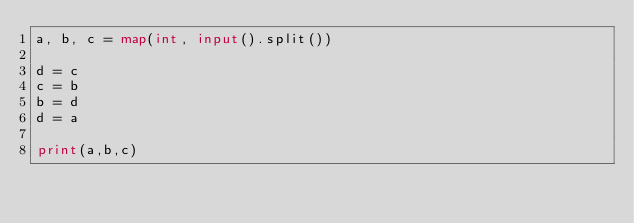Convert code to text. <code><loc_0><loc_0><loc_500><loc_500><_Python_>a, b, c = map(int, input().split())

d = c
c = b 
b = d
d = a
 
print(a,b,c)</code> 